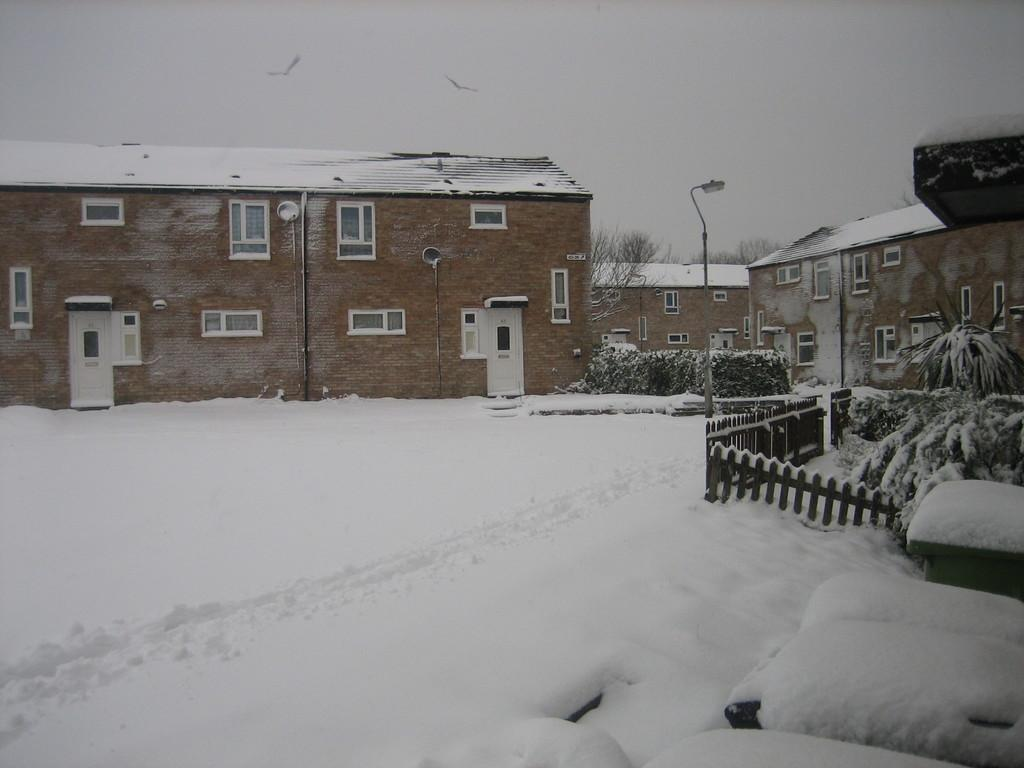What type of structures can be seen in the image? There are buildings in the image. What architectural features are present on the buildings? There are windows and doors visible on the buildings. What is the weather like in the image? There is snow visible in the image, indicating a cold or wintry environment. What type of vegetation is present in the image? There are plants in the image. What type of barrier can be seen in the image? There is fencing in the image. What type of vertical structures are present in the image? There are poles in the image. What is visible in the sky in the image? The sky is visible in the image. What type of animals can be seen in the image? Birds are flying in the air in the image. What type of juice is being served at the drug store in the image? There is no drug store or juice present in the image. Can you describe the man standing near the plants in the image? There is no man present in the image. 